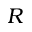Convert formula to latex. <formula><loc_0><loc_0><loc_500><loc_500>R</formula> 